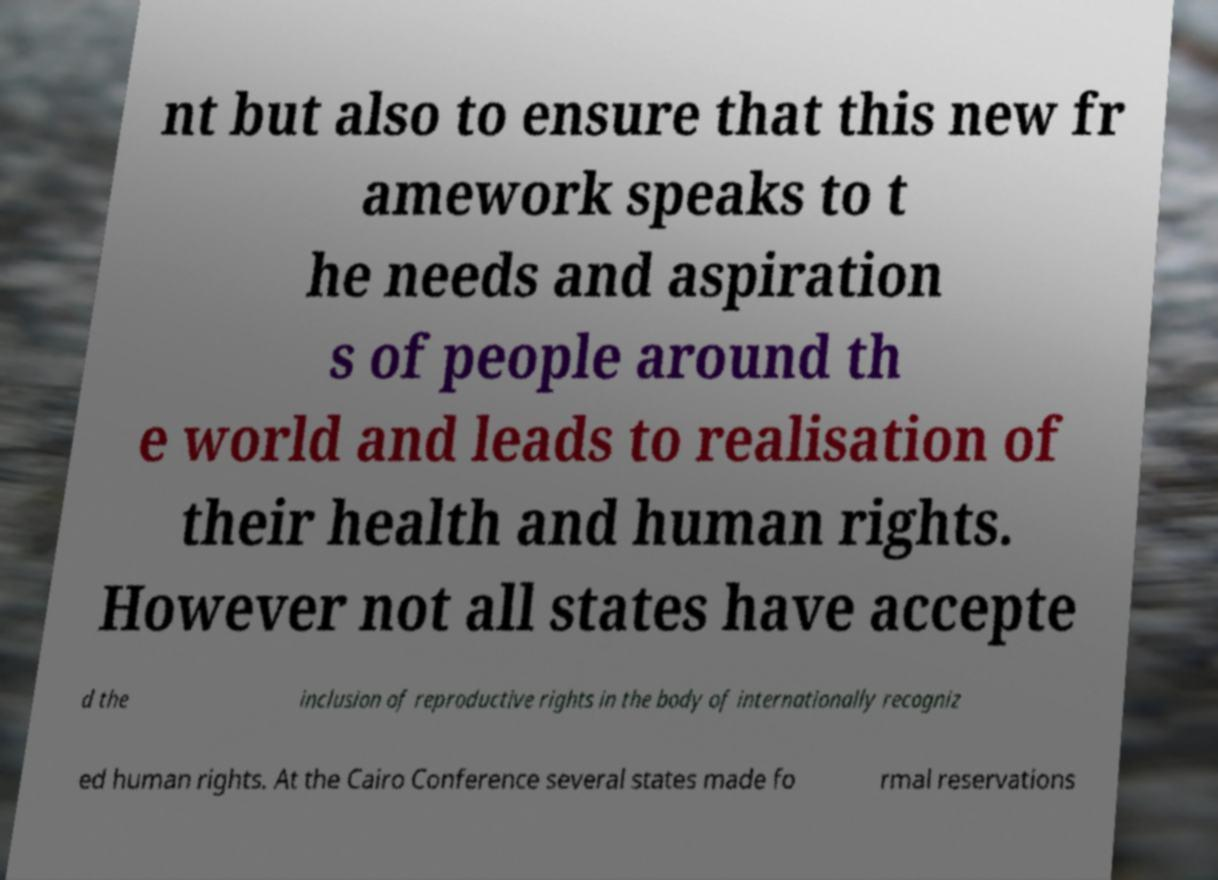There's text embedded in this image that I need extracted. Can you transcribe it verbatim? nt but also to ensure that this new fr amework speaks to t he needs and aspiration s of people around th e world and leads to realisation of their health and human rights. However not all states have accepte d the inclusion of reproductive rights in the body of internationally recogniz ed human rights. At the Cairo Conference several states made fo rmal reservations 